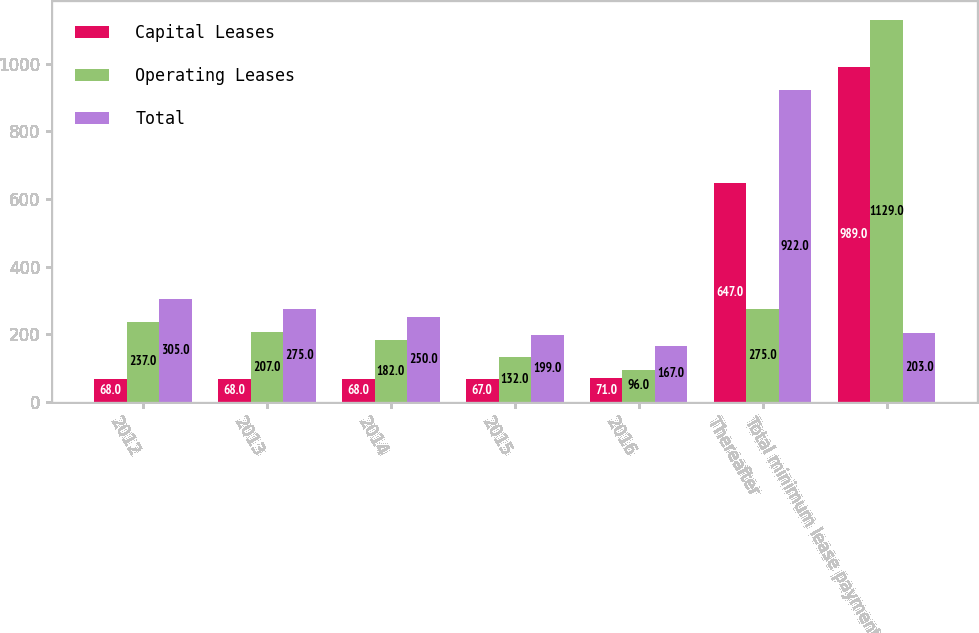Convert chart. <chart><loc_0><loc_0><loc_500><loc_500><stacked_bar_chart><ecel><fcel>2012<fcel>2013<fcel>2014<fcel>2015<fcel>2016<fcel>Thereafter<fcel>Total minimum lease payments<nl><fcel>Capital Leases<fcel>68<fcel>68<fcel>68<fcel>67<fcel>71<fcel>647<fcel>989<nl><fcel>Operating Leases<fcel>237<fcel>207<fcel>182<fcel>132<fcel>96<fcel>275<fcel>1129<nl><fcel>Total<fcel>305<fcel>275<fcel>250<fcel>199<fcel>167<fcel>922<fcel>203<nl></chart> 